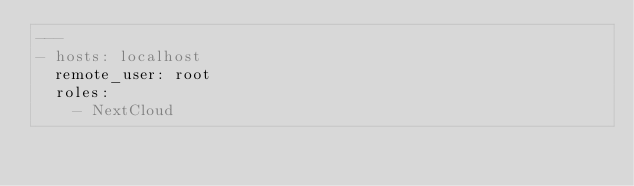Convert code to text. <code><loc_0><loc_0><loc_500><loc_500><_YAML_>---
- hosts: localhost
  remote_user: root
  roles:
    - NextCloud</code> 